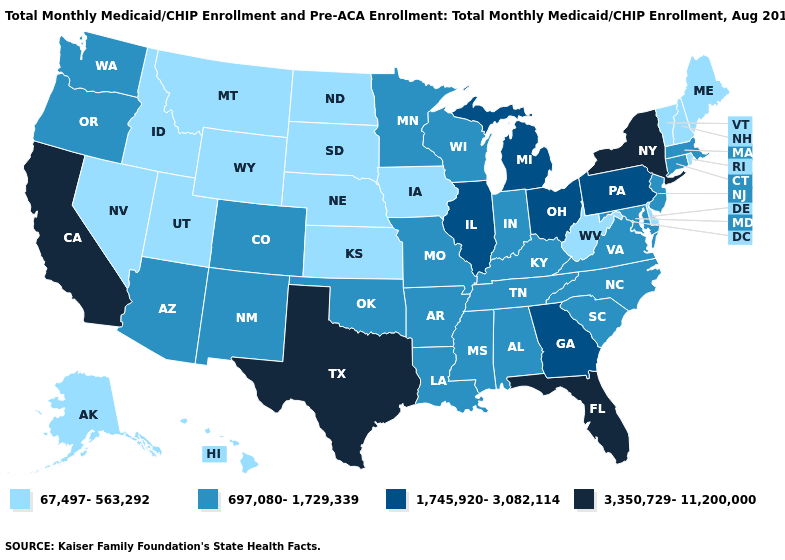What is the lowest value in states that border Utah?
Give a very brief answer. 67,497-563,292. What is the value of Missouri?
Quick response, please. 697,080-1,729,339. Among the states that border Connecticut , which have the lowest value?
Be succinct. Rhode Island. Does Illinois have the highest value in the MidWest?
Short answer required. Yes. Among the states that border Florida , which have the highest value?
Write a very short answer. Georgia. Which states have the highest value in the USA?
Answer briefly. California, Florida, New York, Texas. Does the map have missing data?
Keep it brief. No. Which states have the lowest value in the USA?
Quick response, please. Alaska, Delaware, Hawaii, Idaho, Iowa, Kansas, Maine, Montana, Nebraska, Nevada, New Hampshire, North Dakota, Rhode Island, South Dakota, Utah, Vermont, West Virginia, Wyoming. What is the value of Pennsylvania?
Short answer required. 1,745,920-3,082,114. What is the highest value in the USA?
Write a very short answer. 3,350,729-11,200,000. Name the states that have a value in the range 3,350,729-11,200,000?
Answer briefly. California, Florida, New York, Texas. What is the value of Arkansas?
Short answer required. 697,080-1,729,339. Does Maine have the lowest value in the USA?
Keep it brief. Yes. What is the value of Texas?
Be succinct. 3,350,729-11,200,000. Is the legend a continuous bar?
Short answer required. No. 